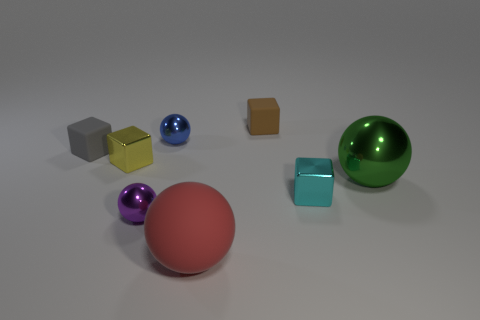How many tiny shiny objects are on the left side of the purple shiny ball and behind the yellow block?
Offer a terse response. 0. Is there anything else of the same color as the large matte object?
Offer a very short reply. No. What is the shape of the cyan thing that is made of the same material as the yellow block?
Keep it short and to the point. Cube. Is the size of the yellow object the same as the brown rubber block?
Keep it short and to the point. Yes. Does the large green ball in front of the small brown thing have the same material as the small brown object?
Keep it short and to the point. No. Are there any other things that have the same material as the green sphere?
Make the answer very short. Yes. There is a small sphere behind the tiny purple metallic sphere that is behind the red thing; how many red spheres are to the right of it?
Your answer should be very brief. 1. Do the tiny thing that is in front of the tiny cyan shiny object and the blue thing have the same shape?
Your answer should be very brief. Yes. How many things are either big green metal blocks or small objects that are on the left side of the big red rubber sphere?
Provide a succinct answer. 4. Is the number of objects that are behind the blue metallic ball greater than the number of tiny metallic objects?
Keep it short and to the point. No. 